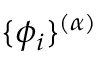Convert formula to latex. <formula><loc_0><loc_0><loc_500><loc_500>\{ \phi _ { i } \} ^ { ( \alpha ) }</formula> 